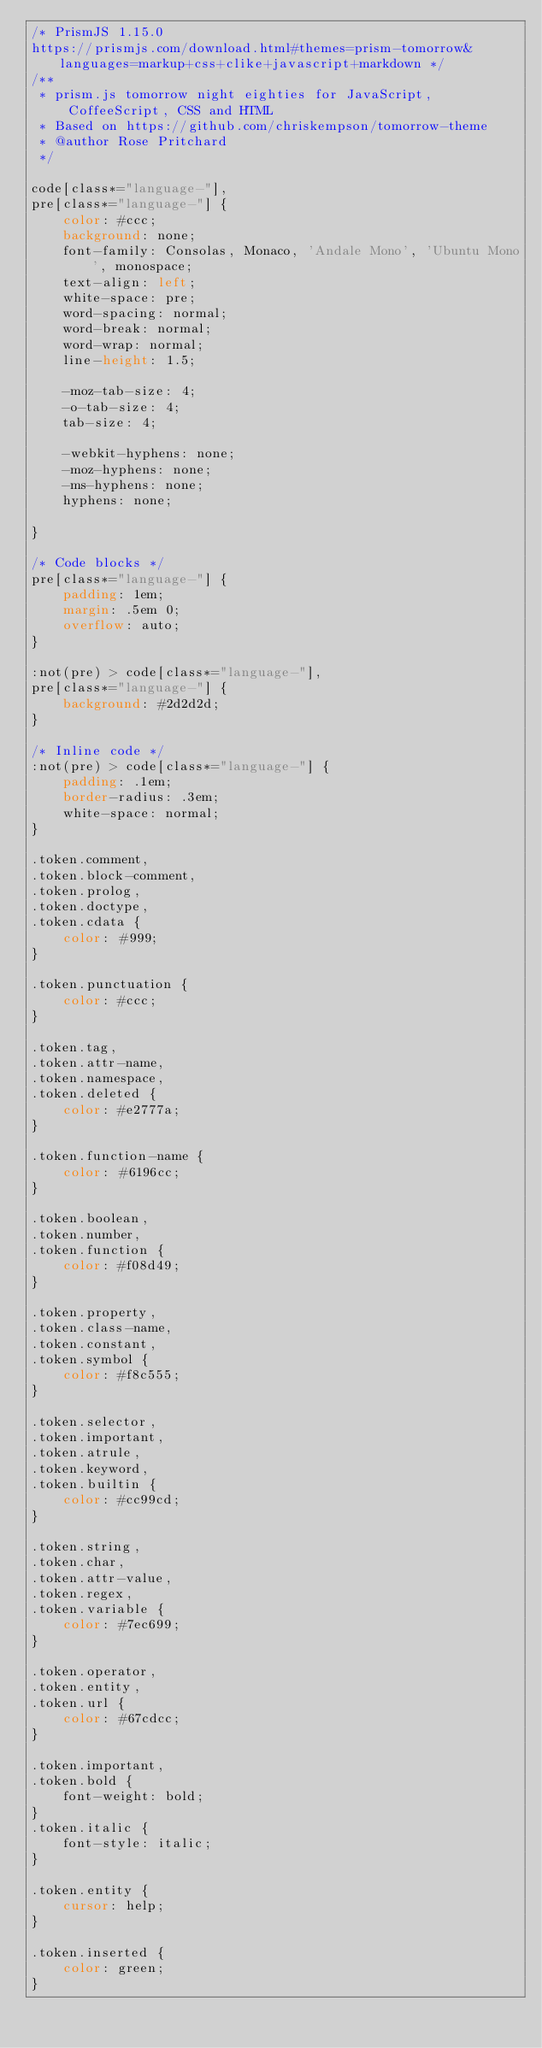Convert code to text. <code><loc_0><loc_0><loc_500><loc_500><_CSS_>/* PrismJS 1.15.0
https://prismjs.com/download.html#themes=prism-tomorrow&languages=markup+css+clike+javascript+markdown */
/**
 * prism.js tomorrow night eighties for JavaScript, CoffeeScript, CSS and HTML
 * Based on https://github.com/chriskempson/tomorrow-theme
 * @author Rose Pritchard
 */

code[class*="language-"],
pre[class*="language-"] {
	color: #ccc;
	background: none;
	font-family: Consolas, Monaco, 'Andale Mono', 'Ubuntu Mono', monospace;
	text-align: left;
	white-space: pre;
	word-spacing: normal;
	word-break: normal;
	word-wrap: normal;
	line-height: 1.5;

	-moz-tab-size: 4;
	-o-tab-size: 4;
	tab-size: 4;

	-webkit-hyphens: none;
	-moz-hyphens: none;
	-ms-hyphens: none;
	hyphens: none;

}

/* Code blocks */
pre[class*="language-"] {
	padding: 1em;
	margin: .5em 0;
	overflow: auto;
}

:not(pre) > code[class*="language-"],
pre[class*="language-"] {
	background: #2d2d2d;
}

/* Inline code */
:not(pre) > code[class*="language-"] {
	padding: .1em;
	border-radius: .3em;
	white-space: normal;
}

.token.comment,
.token.block-comment,
.token.prolog,
.token.doctype,
.token.cdata {
	color: #999;
}

.token.punctuation {
	color: #ccc;
}

.token.tag,
.token.attr-name,
.token.namespace,
.token.deleted {
	color: #e2777a;
}

.token.function-name {
	color: #6196cc;
}

.token.boolean,
.token.number,
.token.function {
	color: #f08d49;
}

.token.property,
.token.class-name,
.token.constant,
.token.symbol {
	color: #f8c555;
}

.token.selector,
.token.important,
.token.atrule,
.token.keyword,
.token.builtin {
	color: #cc99cd;
}

.token.string,
.token.char,
.token.attr-value,
.token.regex,
.token.variable {
	color: #7ec699;
}

.token.operator,
.token.entity,
.token.url {
	color: #67cdcc;
}

.token.important,
.token.bold {
	font-weight: bold;
}
.token.italic {
	font-style: italic;
}

.token.entity {
	cursor: help;
}

.token.inserted {
	color: green;
}

</code> 